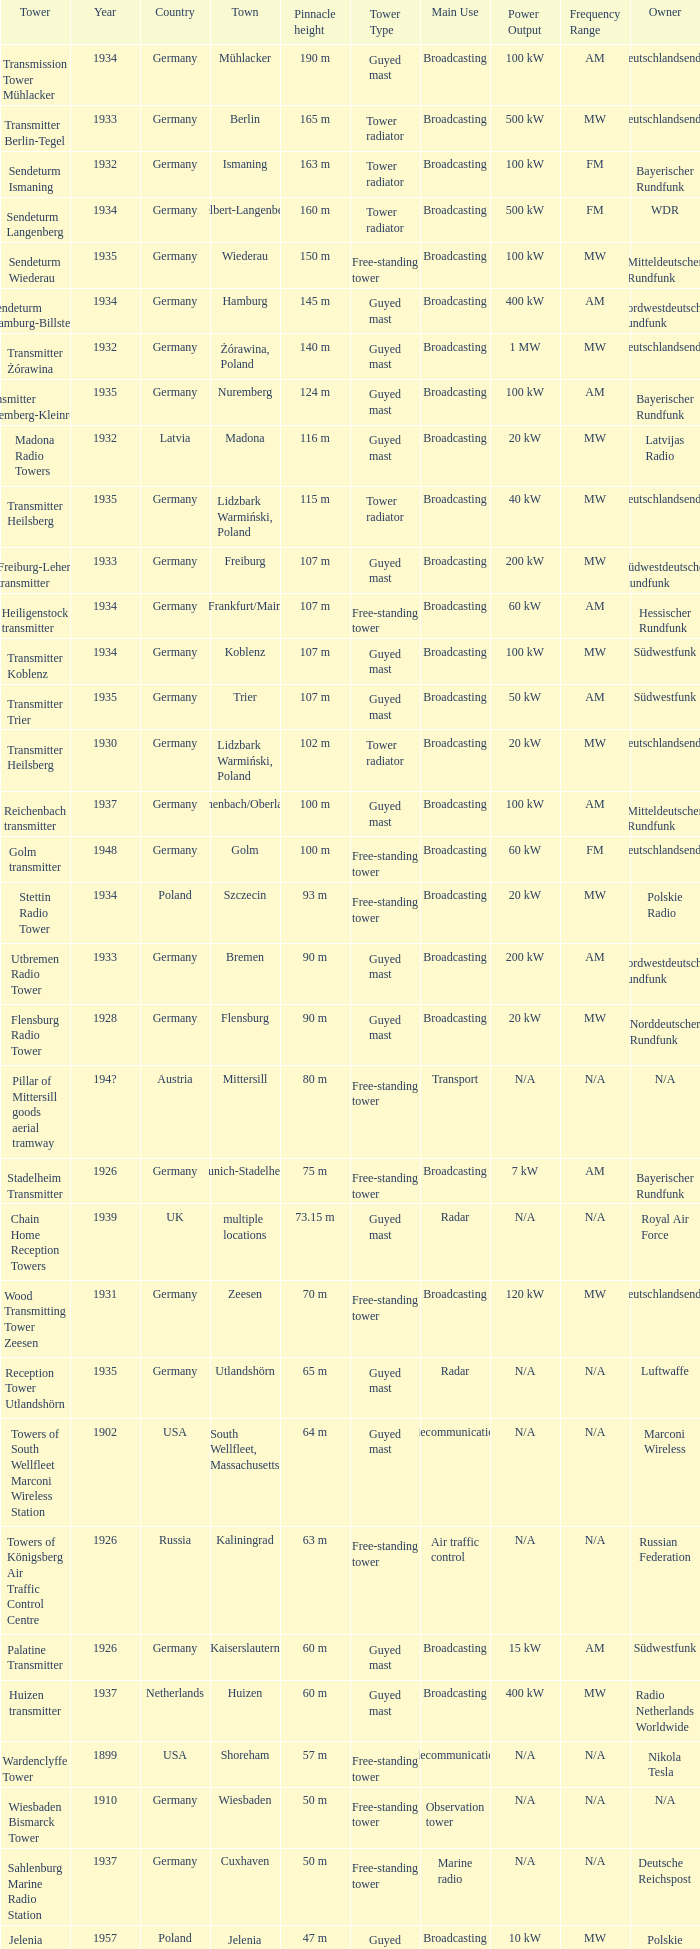Write the full table. {'header': ['Tower', 'Year', 'Country', 'Town', 'Pinnacle height', 'Tower Type', 'Main Use', 'Power Output', 'Frequency Range', 'Owner'], 'rows': [['Transmission Tower Mühlacker', '1934', 'Germany', 'Mühlacker', '190 m', 'Guyed mast', 'Broadcasting', '100 kW', 'AM', 'Deutschlandsender'], ['Transmitter Berlin-Tegel', '1933', 'Germany', 'Berlin', '165 m', 'Tower radiator', 'Broadcasting', '500 kW', 'MW', 'Deutschlandsender'], ['Sendeturm Ismaning', '1932', 'Germany', 'Ismaning', '163 m', 'Tower radiator', 'Broadcasting', '100 kW', 'FM', 'Bayerischer Rundfunk'], ['Sendeturm Langenberg', '1934', 'Germany', 'Velbert-Langenberg', '160 m', 'Tower radiator', 'Broadcasting', '500 kW', 'FM', 'WDR'], ['Sendeturm Wiederau', '1935', 'Germany', 'Wiederau', '150 m', 'Free-standing tower', 'Broadcasting', '100 kW', 'MW', 'Mitteldeutscher Rundfunk'], ['Sendeturm Hamburg-Billstedt', '1934', 'Germany', 'Hamburg', '145 m', 'Guyed mast', 'Broadcasting', '400 kW', 'AM', 'Nordwestdeutscher Rundfunk'], ['Transmitter Żórawina', '1932', 'Germany', 'Żórawina, Poland', '140 m', 'Guyed mast', 'Broadcasting', '1 MW', 'MW', 'Deutschlandsender'], ['Transmitter Nuremberg-Kleinreuth', '1935', 'Germany', 'Nuremberg', '124 m', 'Guyed mast', 'Broadcasting', '100 kW', 'AM', 'Bayerischer Rundfunk'], ['Madona Radio Towers', '1932', 'Latvia', 'Madona', '116 m', 'Guyed mast', 'Broadcasting', '20 kW', 'MW', 'Latvijas Radio'], ['Transmitter Heilsberg', '1935', 'Germany', 'Lidzbark Warmiński, Poland', '115 m', 'Tower radiator', 'Broadcasting', '40 kW', 'MW', 'Deutschlandsender'], ['Freiburg-Lehen transmitter', '1933', 'Germany', 'Freiburg', '107 m', 'Guyed mast', 'Broadcasting', '200 kW', 'MW', 'Südwestdeutscher Rundfunk'], ['Heiligenstock transmitter', '1934', 'Germany', 'Frankfurt/Main', '107 m', 'Free-standing tower', 'Broadcasting', '60 kW', 'AM', 'Hessischer Rundfunk'], ['Transmitter Koblenz', '1934', 'Germany', 'Koblenz', '107 m', 'Guyed mast', 'Broadcasting', '100 kW', 'MW', 'Südwestfunk'], ['Transmitter Trier', '1935', 'Germany', 'Trier', '107 m', 'Guyed mast', 'Broadcasting', '50 kW', 'AM', 'Südwestfunk'], ['Transmitter Heilsberg', '1930', 'Germany', 'Lidzbark Warmiński, Poland', '102 m', 'Tower radiator', 'Broadcasting', '20 kW', 'MW', 'Deutschlandsender'], ['Reichenbach transmitter', '1937', 'Germany', 'Reichenbach/Oberlausitz', '100 m', 'Guyed mast', 'Broadcasting', '100 kW', 'AM', 'Mitteldeutscher Rundfunk'], ['Golm transmitter', '1948', 'Germany', 'Golm', '100 m', 'Free-standing tower', 'Broadcasting', '60 kW', 'FM', 'Deutschlandsender'], ['Stettin Radio Tower', '1934', 'Poland', 'Szczecin', '93 m', 'Free-standing tower', 'Broadcasting', '20 kW', 'MW', 'Polskie Radio'], ['Utbremen Radio Tower', '1933', 'Germany', 'Bremen', '90 m', 'Guyed mast', 'Broadcasting', '200 kW', 'AM', 'Nordwestdeutscher Rundfunk'], ['Flensburg Radio Tower', '1928', 'Germany', 'Flensburg', '90 m', 'Guyed mast', 'Broadcasting', '20 kW', 'MW', 'Norddeutscher Rundfunk'], ['Pillar of Mittersill goods aerial tramway', '194?', 'Austria', 'Mittersill', '80 m', 'Free-standing tower', 'Transport', 'N/A', 'N/A', 'N/A'], ['Stadelheim Transmitter', '1926', 'Germany', 'Munich-Stadelheim', '75 m', 'Free-standing tower', 'Broadcasting', '7 kW', 'AM', 'Bayerischer Rundfunk'], ['Chain Home Reception Towers', '1939', 'UK', 'multiple locations', '73.15 m', 'Guyed mast', 'Radar', 'N/A', 'N/A', 'Royal Air Force'], ['Wood Transmitting Tower Zeesen', '1931', 'Germany', 'Zeesen', '70 m', 'Free-standing tower', 'Broadcasting', '120 kW', 'MW', 'Deutschlandsender'], ['Reception Tower Utlandshörn', '1935', 'Germany', 'Utlandshörn', '65 m', 'Guyed mast', 'Radar', 'N/A', 'N/A', 'Luftwaffe'], ['Towers of South Wellfleet Marconi Wireless Station', '1902', 'USA', 'South Wellfleet, Massachusetts', '64 m', 'Guyed mast', 'Telecommunications', 'N/A', 'N/A', 'Marconi Wireless'], ['Towers of Königsberg Air Traffic Control Centre', '1926', 'Russia', 'Kaliningrad', '63 m', 'Free-standing tower', 'Air traffic control', 'N/A', 'N/A', 'Russian Federation'], ['Palatine Transmitter', '1926', 'Germany', 'Kaiserslautern', '60 m', 'Guyed mast', 'Broadcasting', '15 kW', 'AM', 'Südwestfunk'], ['Huizen transmitter', '1937', 'Netherlands', 'Huizen', '60 m', 'Guyed mast', 'Broadcasting', '400 kW', 'MW', 'Radio Netherlands Worldwide'], ['Wardenclyffe Tower', '1899', 'USA', 'Shoreham', '57 m', 'Free-standing tower', 'Telecommunications', 'N/A', 'N/A', 'Nikola Tesla'], ['Wiesbaden Bismarck Tower', '1910', 'Germany', 'Wiesbaden', '50 m', 'Free-standing tower', 'Observation tower', 'N/A', 'N/A', 'N/A'], ['Sahlenburg Marine Radio Station', '1937', 'Germany', 'Cuxhaven', '50 m', 'Free-standing tower', 'Marine radio', 'N/A', 'N/A', 'Deutsche Reichspost'], ['Jelenia Góra transmitter', '1957', 'Poland', 'Jelenia Góra', '47 m', 'Guyed mast', 'Broadcasting', '10 kW', 'MW', 'Polskie Radio'], ['Towers of triangle antenna Langenberg', '1935', 'Germany', 'Velbert-Langenberg', '45 m', 'Guyed mast', 'Broadcasting', '100 kW', 'FM', 'WDR'], ['Kempten-Engelshalde Transmitter', '1951', 'Germany', 'Kempten', '40 m', 'Guyed mast', 'Broadcasting', '200 kW', 'MW', 'Bayerischer Rundfunk'], ['Heusweiler Mast 1', '1935', 'Germany', 'Heusweiler', '35 m', 'Lattice tower', 'Broadcasting', '40 kW', 'FM', 'Saarländischer Rundfunk'], ['Heusweiler Mast 2', '1935', 'Germany', 'Heusweiler', '31 m', 'Lattice tower', 'Broadcasting', '20 kW', 'FM', 'Saarländischer Rundfunk']]} Which country had a tower destroyed in 1899? USA. 